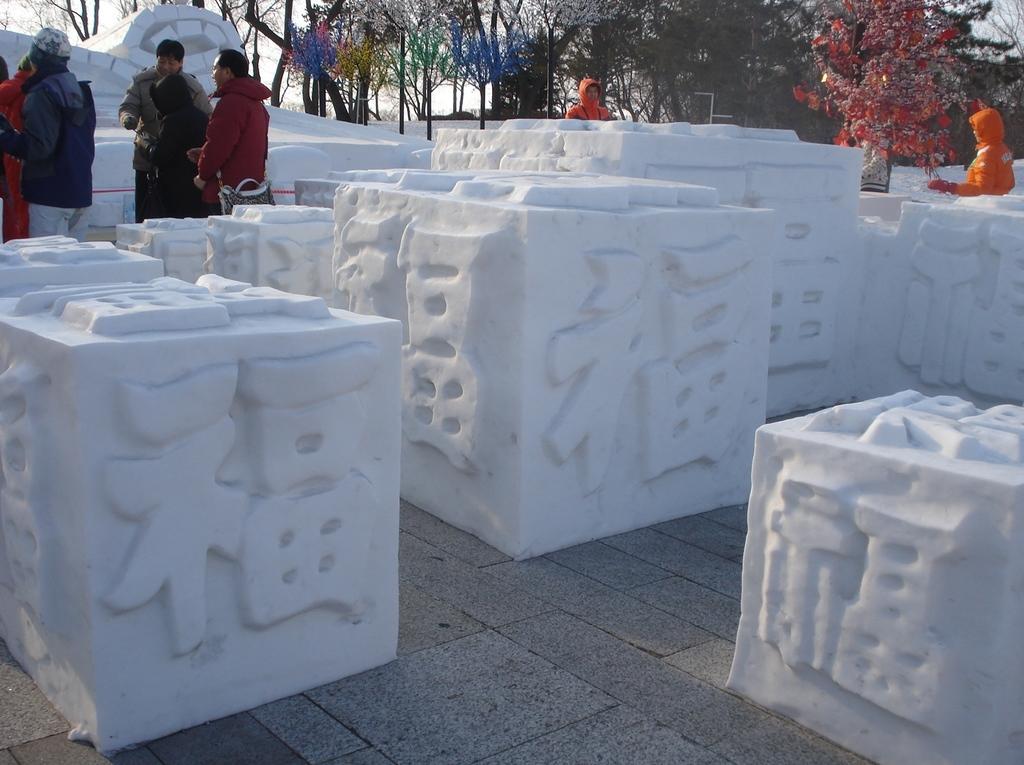How would you summarize this image in a sentence or two? In this image we can see blocks made with stone. In the background there are people standing and there are trees. 